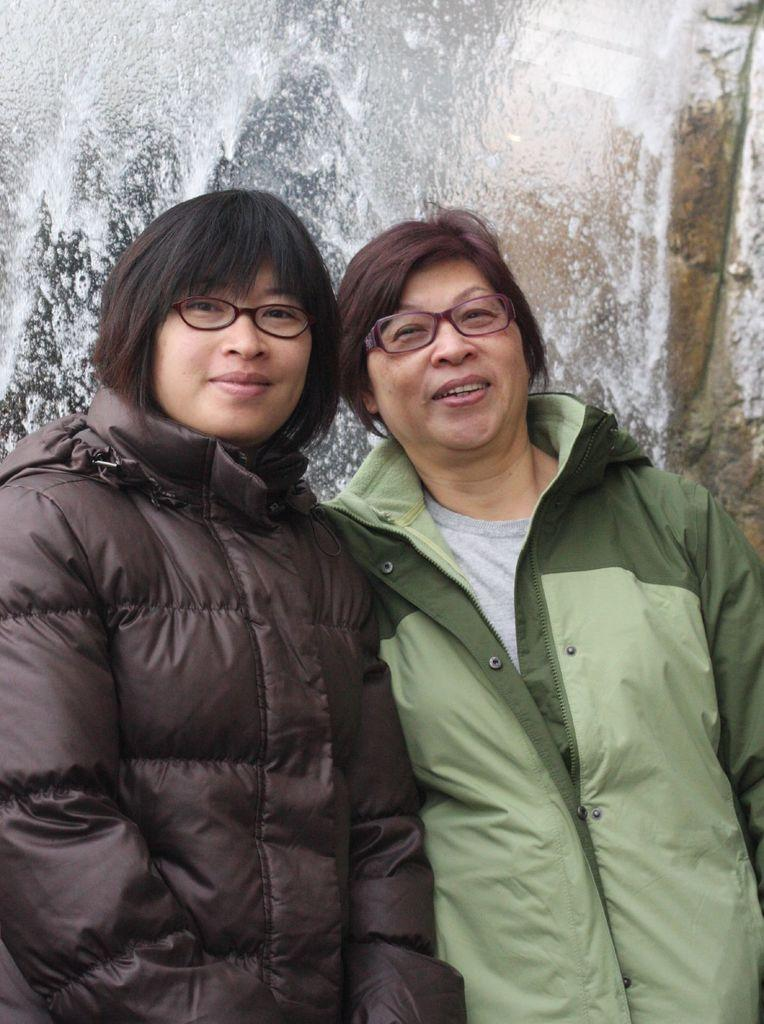How many people are in the image? There are two persons in the image. What are the persons wearing? The persons are wearing jackets and glasses. What can be seen in the background of the image? There is a waterfall in the background of the image. What type of balls are being used by the persons in the image? There are no balls present in the image; the persons are wearing glasses and jackets. 